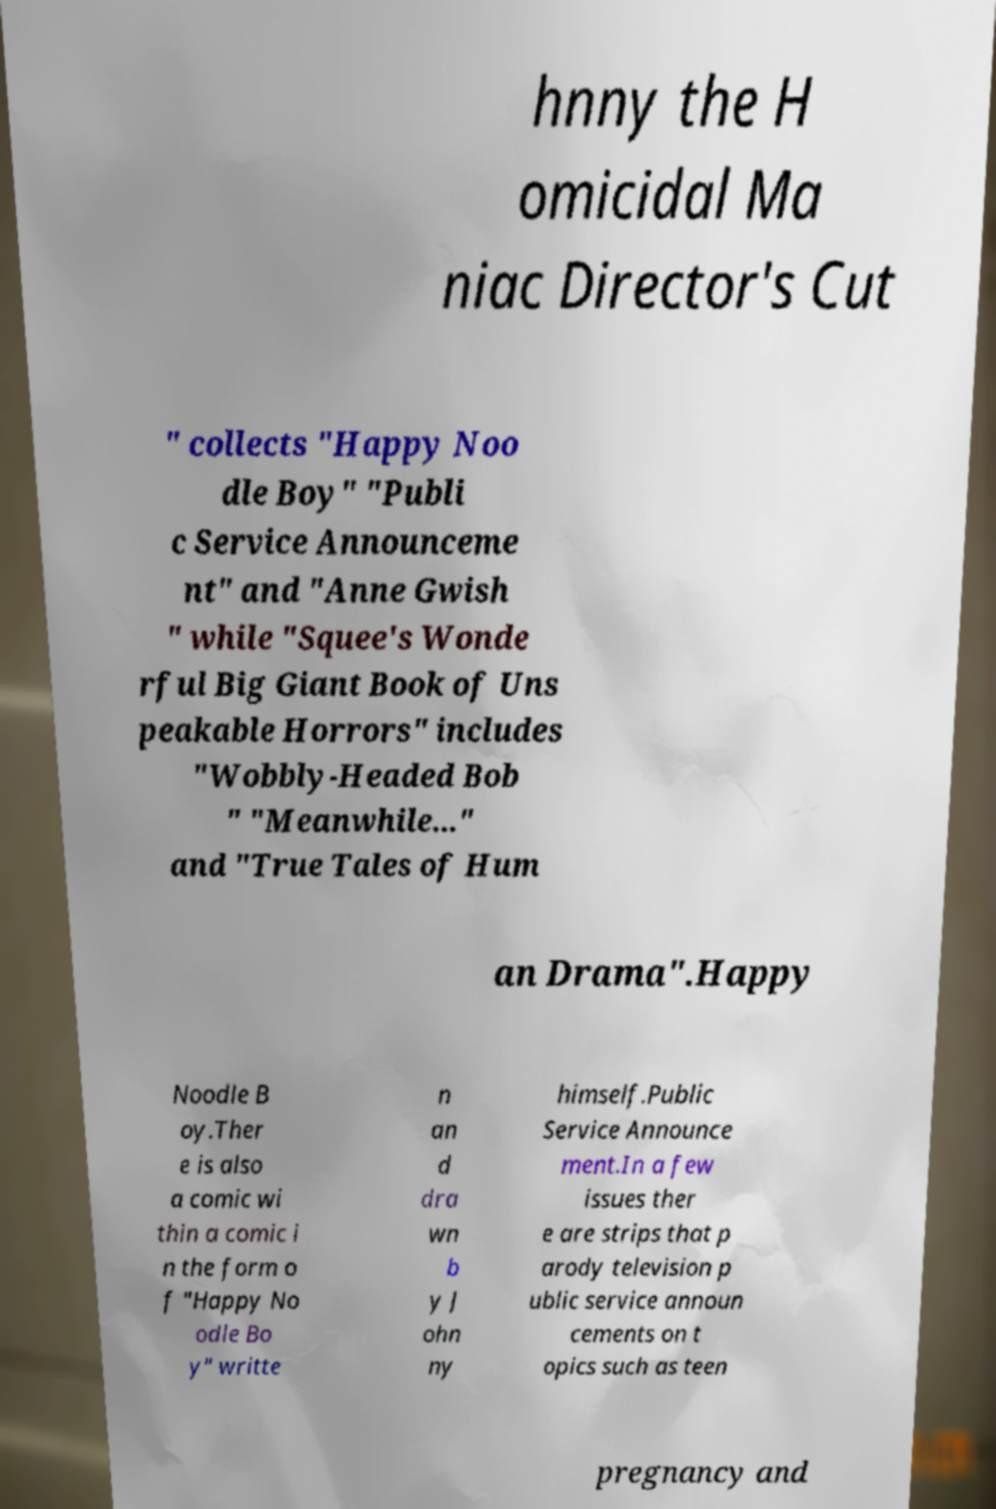I need the written content from this picture converted into text. Can you do that? hnny the H omicidal Ma niac Director's Cut " collects "Happy Noo dle Boy" "Publi c Service Announceme nt" and "Anne Gwish " while "Squee's Wonde rful Big Giant Book of Uns peakable Horrors" includes "Wobbly-Headed Bob " "Meanwhile..." and "True Tales of Hum an Drama".Happy Noodle B oy.Ther e is also a comic wi thin a comic i n the form o f "Happy No odle Bo y" writte n an d dra wn b y J ohn ny himself.Public Service Announce ment.In a few issues ther e are strips that p arody television p ublic service announ cements on t opics such as teen pregnancy and 